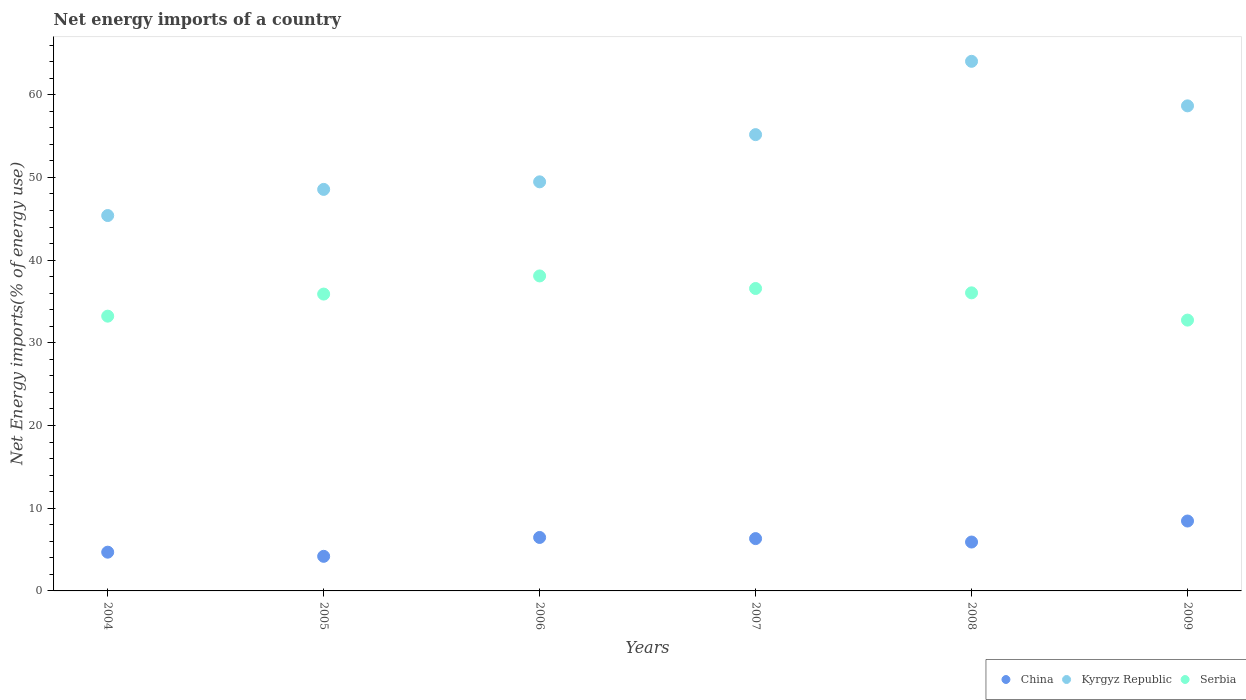How many different coloured dotlines are there?
Your response must be concise. 3. Is the number of dotlines equal to the number of legend labels?
Ensure brevity in your answer.  Yes. What is the net energy imports in Serbia in 2004?
Provide a succinct answer. 33.23. Across all years, what is the maximum net energy imports in China?
Provide a succinct answer. 8.45. Across all years, what is the minimum net energy imports in Kyrgyz Republic?
Offer a very short reply. 45.39. In which year was the net energy imports in Serbia maximum?
Offer a very short reply. 2006. In which year was the net energy imports in Serbia minimum?
Provide a succinct answer. 2009. What is the total net energy imports in Kyrgyz Republic in the graph?
Provide a short and direct response. 321.3. What is the difference between the net energy imports in Serbia in 2006 and that in 2009?
Your answer should be very brief. 5.34. What is the difference between the net energy imports in Kyrgyz Republic in 2008 and the net energy imports in Serbia in 2009?
Your answer should be compact. 31.29. What is the average net energy imports in Serbia per year?
Offer a very short reply. 35.43. In the year 2009, what is the difference between the net energy imports in China and net energy imports in Kyrgyz Republic?
Give a very brief answer. -50.21. What is the ratio of the net energy imports in Kyrgyz Republic in 2005 to that in 2009?
Your answer should be compact. 0.83. What is the difference between the highest and the second highest net energy imports in Kyrgyz Republic?
Ensure brevity in your answer.  5.38. What is the difference between the highest and the lowest net energy imports in Kyrgyz Republic?
Provide a short and direct response. 18.65. Is the sum of the net energy imports in Serbia in 2004 and 2006 greater than the maximum net energy imports in China across all years?
Your response must be concise. Yes. Does the net energy imports in Serbia monotonically increase over the years?
Provide a short and direct response. No. How many dotlines are there?
Ensure brevity in your answer.  3. What is the difference between two consecutive major ticks on the Y-axis?
Offer a very short reply. 10. Does the graph contain any zero values?
Your answer should be compact. No. Where does the legend appear in the graph?
Provide a succinct answer. Bottom right. What is the title of the graph?
Provide a succinct answer. Net energy imports of a country. Does "Brunei Darussalam" appear as one of the legend labels in the graph?
Offer a terse response. No. What is the label or title of the Y-axis?
Give a very brief answer. Net Energy imports(% of energy use). What is the Net Energy imports(% of energy use) in China in 2004?
Make the answer very short. 4.69. What is the Net Energy imports(% of energy use) in Kyrgyz Republic in 2004?
Keep it short and to the point. 45.39. What is the Net Energy imports(% of energy use) in Serbia in 2004?
Provide a short and direct response. 33.23. What is the Net Energy imports(% of energy use) in China in 2005?
Your response must be concise. 4.18. What is the Net Energy imports(% of energy use) of Kyrgyz Republic in 2005?
Offer a very short reply. 48.56. What is the Net Energy imports(% of energy use) of Serbia in 2005?
Offer a very short reply. 35.9. What is the Net Energy imports(% of energy use) in China in 2006?
Provide a short and direct response. 6.47. What is the Net Energy imports(% of energy use) of Kyrgyz Republic in 2006?
Provide a succinct answer. 49.47. What is the Net Energy imports(% of energy use) of Serbia in 2006?
Offer a very short reply. 38.09. What is the Net Energy imports(% of energy use) of China in 2007?
Your answer should be very brief. 6.33. What is the Net Energy imports(% of energy use) in Kyrgyz Republic in 2007?
Ensure brevity in your answer.  55.18. What is the Net Energy imports(% of energy use) of Serbia in 2007?
Your answer should be very brief. 36.57. What is the Net Energy imports(% of energy use) of China in 2008?
Offer a very short reply. 5.91. What is the Net Energy imports(% of energy use) in Kyrgyz Republic in 2008?
Provide a short and direct response. 64.04. What is the Net Energy imports(% of energy use) in Serbia in 2008?
Ensure brevity in your answer.  36.05. What is the Net Energy imports(% of energy use) of China in 2009?
Provide a short and direct response. 8.45. What is the Net Energy imports(% of energy use) in Kyrgyz Republic in 2009?
Your response must be concise. 58.66. What is the Net Energy imports(% of energy use) in Serbia in 2009?
Offer a terse response. 32.75. Across all years, what is the maximum Net Energy imports(% of energy use) in China?
Ensure brevity in your answer.  8.45. Across all years, what is the maximum Net Energy imports(% of energy use) in Kyrgyz Republic?
Give a very brief answer. 64.04. Across all years, what is the maximum Net Energy imports(% of energy use) of Serbia?
Give a very brief answer. 38.09. Across all years, what is the minimum Net Energy imports(% of energy use) in China?
Offer a very short reply. 4.18. Across all years, what is the minimum Net Energy imports(% of energy use) of Kyrgyz Republic?
Your response must be concise. 45.39. Across all years, what is the minimum Net Energy imports(% of energy use) of Serbia?
Give a very brief answer. 32.75. What is the total Net Energy imports(% of energy use) in China in the graph?
Your answer should be very brief. 36.03. What is the total Net Energy imports(% of energy use) in Kyrgyz Republic in the graph?
Keep it short and to the point. 321.3. What is the total Net Energy imports(% of energy use) in Serbia in the graph?
Ensure brevity in your answer.  212.58. What is the difference between the Net Energy imports(% of energy use) of China in 2004 and that in 2005?
Offer a terse response. 0.5. What is the difference between the Net Energy imports(% of energy use) in Kyrgyz Republic in 2004 and that in 2005?
Offer a terse response. -3.16. What is the difference between the Net Energy imports(% of energy use) in Serbia in 2004 and that in 2005?
Your answer should be very brief. -2.67. What is the difference between the Net Energy imports(% of energy use) in China in 2004 and that in 2006?
Keep it short and to the point. -1.78. What is the difference between the Net Energy imports(% of energy use) of Kyrgyz Republic in 2004 and that in 2006?
Give a very brief answer. -4.08. What is the difference between the Net Energy imports(% of energy use) in Serbia in 2004 and that in 2006?
Keep it short and to the point. -4.86. What is the difference between the Net Energy imports(% of energy use) of China in 2004 and that in 2007?
Your response must be concise. -1.64. What is the difference between the Net Energy imports(% of energy use) in Kyrgyz Republic in 2004 and that in 2007?
Provide a short and direct response. -9.78. What is the difference between the Net Energy imports(% of energy use) of Serbia in 2004 and that in 2007?
Give a very brief answer. -3.34. What is the difference between the Net Energy imports(% of energy use) of China in 2004 and that in 2008?
Your response must be concise. -1.23. What is the difference between the Net Energy imports(% of energy use) of Kyrgyz Republic in 2004 and that in 2008?
Provide a short and direct response. -18.65. What is the difference between the Net Energy imports(% of energy use) in Serbia in 2004 and that in 2008?
Provide a succinct answer. -2.82. What is the difference between the Net Energy imports(% of energy use) of China in 2004 and that in 2009?
Offer a terse response. -3.77. What is the difference between the Net Energy imports(% of energy use) of Kyrgyz Republic in 2004 and that in 2009?
Your response must be concise. -13.26. What is the difference between the Net Energy imports(% of energy use) in Serbia in 2004 and that in 2009?
Make the answer very short. 0.48. What is the difference between the Net Energy imports(% of energy use) of China in 2005 and that in 2006?
Provide a succinct answer. -2.28. What is the difference between the Net Energy imports(% of energy use) in Kyrgyz Republic in 2005 and that in 2006?
Your answer should be compact. -0.91. What is the difference between the Net Energy imports(% of energy use) in Serbia in 2005 and that in 2006?
Make the answer very short. -2.19. What is the difference between the Net Energy imports(% of energy use) in China in 2005 and that in 2007?
Keep it short and to the point. -2.14. What is the difference between the Net Energy imports(% of energy use) of Kyrgyz Republic in 2005 and that in 2007?
Provide a succinct answer. -6.62. What is the difference between the Net Energy imports(% of energy use) of Serbia in 2005 and that in 2007?
Keep it short and to the point. -0.67. What is the difference between the Net Energy imports(% of energy use) of China in 2005 and that in 2008?
Offer a terse response. -1.73. What is the difference between the Net Energy imports(% of energy use) in Kyrgyz Republic in 2005 and that in 2008?
Ensure brevity in your answer.  -15.49. What is the difference between the Net Energy imports(% of energy use) of Serbia in 2005 and that in 2008?
Make the answer very short. -0.15. What is the difference between the Net Energy imports(% of energy use) in China in 2005 and that in 2009?
Ensure brevity in your answer.  -4.27. What is the difference between the Net Energy imports(% of energy use) of Kyrgyz Republic in 2005 and that in 2009?
Ensure brevity in your answer.  -10.1. What is the difference between the Net Energy imports(% of energy use) in Serbia in 2005 and that in 2009?
Offer a terse response. 3.15. What is the difference between the Net Energy imports(% of energy use) in China in 2006 and that in 2007?
Provide a short and direct response. 0.14. What is the difference between the Net Energy imports(% of energy use) of Kyrgyz Republic in 2006 and that in 2007?
Ensure brevity in your answer.  -5.71. What is the difference between the Net Energy imports(% of energy use) of Serbia in 2006 and that in 2007?
Make the answer very short. 1.52. What is the difference between the Net Energy imports(% of energy use) in China in 2006 and that in 2008?
Ensure brevity in your answer.  0.55. What is the difference between the Net Energy imports(% of energy use) of Kyrgyz Republic in 2006 and that in 2008?
Your response must be concise. -14.57. What is the difference between the Net Energy imports(% of energy use) of Serbia in 2006 and that in 2008?
Your answer should be compact. 2.04. What is the difference between the Net Energy imports(% of energy use) in China in 2006 and that in 2009?
Your answer should be compact. -1.99. What is the difference between the Net Energy imports(% of energy use) in Kyrgyz Republic in 2006 and that in 2009?
Provide a short and direct response. -9.19. What is the difference between the Net Energy imports(% of energy use) in Serbia in 2006 and that in 2009?
Ensure brevity in your answer.  5.34. What is the difference between the Net Energy imports(% of energy use) of China in 2007 and that in 2008?
Your answer should be very brief. 0.42. What is the difference between the Net Energy imports(% of energy use) of Kyrgyz Republic in 2007 and that in 2008?
Your response must be concise. -8.86. What is the difference between the Net Energy imports(% of energy use) in Serbia in 2007 and that in 2008?
Provide a succinct answer. 0.53. What is the difference between the Net Energy imports(% of energy use) in China in 2007 and that in 2009?
Provide a succinct answer. -2.13. What is the difference between the Net Energy imports(% of energy use) in Kyrgyz Republic in 2007 and that in 2009?
Offer a very short reply. -3.48. What is the difference between the Net Energy imports(% of energy use) in Serbia in 2007 and that in 2009?
Your answer should be compact. 3.82. What is the difference between the Net Energy imports(% of energy use) in China in 2008 and that in 2009?
Keep it short and to the point. -2.54. What is the difference between the Net Energy imports(% of energy use) of Kyrgyz Republic in 2008 and that in 2009?
Ensure brevity in your answer.  5.38. What is the difference between the Net Energy imports(% of energy use) of Serbia in 2008 and that in 2009?
Provide a short and direct response. 3.3. What is the difference between the Net Energy imports(% of energy use) in China in 2004 and the Net Energy imports(% of energy use) in Kyrgyz Republic in 2005?
Offer a very short reply. -43.87. What is the difference between the Net Energy imports(% of energy use) of China in 2004 and the Net Energy imports(% of energy use) of Serbia in 2005?
Offer a very short reply. -31.21. What is the difference between the Net Energy imports(% of energy use) of Kyrgyz Republic in 2004 and the Net Energy imports(% of energy use) of Serbia in 2005?
Provide a succinct answer. 9.5. What is the difference between the Net Energy imports(% of energy use) in China in 2004 and the Net Energy imports(% of energy use) in Kyrgyz Republic in 2006?
Your answer should be very brief. -44.78. What is the difference between the Net Energy imports(% of energy use) in China in 2004 and the Net Energy imports(% of energy use) in Serbia in 2006?
Provide a short and direct response. -33.4. What is the difference between the Net Energy imports(% of energy use) in Kyrgyz Republic in 2004 and the Net Energy imports(% of energy use) in Serbia in 2006?
Make the answer very short. 7.3. What is the difference between the Net Energy imports(% of energy use) in China in 2004 and the Net Energy imports(% of energy use) in Kyrgyz Republic in 2007?
Offer a terse response. -50.49. What is the difference between the Net Energy imports(% of energy use) of China in 2004 and the Net Energy imports(% of energy use) of Serbia in 2007?
Offer a terse response. -31.89. What is the difference between the Net Energy imports(% of energy use) of Kyrgyz Republic in 2004 and the Net Energy imports(% of energy use) of Serbia in 2007?
Provide a short and direct response. 8.82. What is the difference between the Net Energy imports(% of energy use) of China in 2004 and the Net Energy imports(% of energy use) of Kyrgyz Republic in 2008?
Keep it short and to the point. -59.36. What is the difference between the Net Energy imports(% of energy use) of China in 2004 and the Net Energy imports(% of energy use) of Serbia in 2008?
Provide a succinct answer. -31.36. What is the difference between the Net Energy imports(% of energy use) in Kyrgyz Republic in 2004 and the Net Energy imports(% of energy use) in Serbia in 2008?
Make the answer very short. 9.35. What is the difference between the Net Energy imports(% of energy use) of China in 2004 and the Net Energy imports(% of energy use) of Kyrgyz Republic in 2009?
Give a very brief answer. -53.97. What is the difference between the Net Energy imports(% of energy use) in China in 2004 and the Net Energy imports(% of energy use) in Serbia in 2009?
Provide a short and direct response. -28.06. What is the difference between the Net Energy imports(% of energy use) in Kyrgyz Republic in 2004 and the Net Energy imports(% of energy use) in Serbia in 2009?
Provide a succinct answer. 12.64. What is the difference between the Net Energy imports(% of energy use) in China in 2005 and the Net Energy imports(% of energy use) in Kyrgyz Republic in 2006?
Make the answer very short. -45.29. What is the difference between the Net Energy imports(% of energy use) of China in 2005 and the Net Energy imports(% of energy use) of Serbia in 2006?
Your response must be concise. -33.91. What is the difference between the Net Energy imports(% of energy use) of Kyrgyz Republic in 2005 and the Net Energy imports(% of energy use) of Serbia in 2006?
Provide a short and direct response. 10.47. What is the difference between the Net Energy imports(% of energy use) in China in 2005 and the Net Energy imports(% of energy use) in Kyrgyz Republic in 2007?
Offer a very short reply. -50.99. What is the difference between the Net Energy imports(% of energy use) in China in 2005 and the Net Energy imports(% of energy use) in Serbia in 2007?
Ensure brevity in your answer.  -32.39. What is the difference between the Net Energy imports(% of energy use) in Kyrgyz Republic in 2005 and the Net Energy imports(% of energy use) in Serbia in 2007?
Keep it short and to the point. 11.98. What is the difference between the Net Energy imports(% of energy use) in China in 2005 and the Net Energy imports(% of energy use) in Kyrgyz Republic in 2008?
Offer a very short reply. -59.86. What is the difference between the Net Energy imports(% of energy use) in China in 2005 and the Net Energy imports(% of energy use) in Serbia in 2008?
Offer a terse response. -31.86. What is the difference between the Net Energy imports(% of energy use) in Kyrgyz Republic in 2005 and the Net Energy imports(% of energy use) in Serbia in 2008?
Provide a short and direct response. 12.51. What is the difference between the Net Energy imports(% of energy use) in China in 2005 and the Net Energy imports(% of energy use) in Kyrgyz Republic in 2009?
Give a very brief answer. -54.47. What is the difference between the Net Energy imports(% of energy use) in China in 2005 and the Net Energy imports(% of energy use) in Serbia in 2009?
Ensure brevity in your answer.  -28.57. What is the difference between the Net Energy imports(% of energy use) of Kyrgyz Republic in 2005 and the Net Energy imports(% of energy use) of Serbia in 2009?
Your answer should be very brief. 15.81. What is the difference between the Net Energy imports(% of energy use) of China in 2006 and the Net Energy imports(% of energy use) of Kyrgyz Republic in 2007?
Your response must be concise. -48.71. What is the difference between the Net Energy imports(% of energy use) in China in 2006 and the Net Energy imports(% of energy use) in Serbia in 2007?
Provide a succinct answer. -30.11. What is the difference between the Net Energy imports(% of energy use) in Kyrgyz Republic in 2006 and the Net Energy imports(% of energy use) in Serbia in 2007?
Keep it short and to the point. 12.9. What is the difference between the Net Energy imports(% of energy use) of China in 2006 and the Net Energy imports(% of energy use) of Kyrgyz Republic in 2008?
Your answer should be very brief. -57.58. What is the difference between the Net Energy imports(% of energy use) of China in 2006 and the Net Energy imports(% of energy use) of Serbia in 2008?
Offer a very short reply. -29.58. What is the difference between the Net Energy imports(% of energy use) of Kyrgyz Republic in 2006 and the Net Energy imports(% of energy use) of Serbia in 2008?
Give a very brief answer. 13.42. What is the difference between the Net Energy imports(% of energy use) of China in 2006 and the Net Energy imports(% of energy use) of Kyrgyz Republic in 2009?
Give a very brief answer. -52.19. What is the difference between the Net Energy imports(% of energy use) in China in 2006 and the Net Energy imports(% of energy use) in Serbia in 2009?
Give a very brief answer. -26.28. What is the difference between the Net Energy imports(% of energy use) in Kyrgyz Republic in 2006 and the Net Energy imports(% of energy use) in Serbia in 2009?
Your answer should be very brief. 16.72. What is the difference between the Net Energy imports(% of energy use) of China in 2007 and the Net Energy imports(% of energy use) of Kyrgyz Republic in 2008?
Your response must be concise. -57.72. What is the difference between the Net Energy imports(% of energy use) of China in 2007 and the Net Energy imports(% of energy use) of Serbia in 2008?
Give a very brief answer. -29.72. What is the difference between the Net Energy imports(% of energy use) of Kyrgyz Republic in 2007 and the Net Energy imports(% of energy use) of Serbia in 2008?
Provide a succinct answer. 19.13. What is the difference between the Net Energy imports(% of energy use) in China in 2007 and the Net Energy imports(% of energy use) in Kyrgyz Republic in 2009?
Your answer should be very brief. -52.33. What is the difference between the Net Energy imports(% of energy use) in China in 2007 and the Net Energy imports(% of energy use) in Serbia in 2009?
Your response must be concise. -26.42. What is the difference between the Net Energy imports(% of energy use) of Kyrgyz Republic in 2007 and the Net Energy imports(% of energy use) of Serbia in 2009?
Your answer should be very brief. 22.43. What is the difference between the Net Energy imports(% of energy use) in China in 2008 and the Net Energy imports(% of energy use) in Kyrgyz Republic in 2009?
Ensure brevity in your answer.  -52.75. What is the difference between the Net Energy imports(% of energy use) in China in 2008 and the Net Energy imports(% of energy use) in Serbia in 2009?
Ensure brevity in your answer.  -26.84. What is the difference between the Net Energy imports(% of energy use) in Kyrgyz Republic in 2008 and the Net Energy imports(% of energy use) in Serbia in 2009?
Keep it short and to the point. 31.29. What is the average Net Energy imports(% of energy use) in China per year?
Ensure brevity in your answer.  6. What is the average Net Energy imports(% of energy use) in Kyrgyz Republic per year?
Make the answer very short. 53.55. What is the average Net Energy imports(% of energy use) of Serbia per year?
Your answer should be compact. 35.43. In the year 2004, what is the difference between the Net Energy imports(% of energy use) in China and Net Energy imports(% of energy use) in Kyrgyz Republic?
Make the answer very short. -40.71. In the year 2004, what is the difference between the Net Energy imports(% of energy use) of China and Net Energy imports(% of energy use) of Serbia?
Give a very brief answer. -28.54. In the year 2004, what is the difference between the Net Energy imports(% of energy use) in Kyrgyz Republic and Net Energy imports(% of energy use) in Serbia?
Your answer should be very brief. 12.17. In the year 2005, what is the difference between the Net Energy imports(% of energy use) of China and Net Energy imports(% of energy use) of Kyrgyz Republic?
Your answer should be compact. -44.37. In the year 2005, what is the difference between the Net Energy imports(% of energy use) in China and Net Energy imports(% of energy use) in Serbia?
Provide a succinct answer. -31.71. In the year 2005, what is the difference between the Net Energy imports(% of energy use) of Kyrgyz Republic and Net Energy imports(% of energy use) of Serbia?
Your answer should be very brief. 12.66. In the year 2006, what is the difference between the Net Energy imports(% of energy use) of China and Net Energy imports(% of energy use) of Kyrgyz Republic?
Give a very brief answer. -43. In the year 2006, what is the difference between the Net Energy imports(% of energy use) in China and Net Energy imports(% of energy use) in Serbia?
Your answer should be very brief. -31.62. In the year 2006, what is the difference between the Net Energy imports(% of energy use) of Kyrgyz Republic and Net Energy imports(% of energy use) of Serbia?
Your answer should be compact. 11.38. In the year 2007, what is the difference between the Net Energy imports(% of energy use) in China and Net Energy imports(% of energy use) in Kyrgyz Republic?
Ensure brevity in your answer.  -48.85. In the year 2007, what is the difference between the Net Energy imports(% of energy use) of China and Net Energy imports(% of energy use) of Serbia?
Keep it short and to the point. -30.24. In the year 2007, what is the difference between the Net Energy imports(% of energy use) of Kyrgyz Republic and Net Energy imports(% of energy use) of Serbia?
Your answer should be very brief. 18.61. In the year 2008, what is the difference between the Net Energy imports(% of energy use) of China and Net Energy imports(% of energy use) of Kyrgyz Republic?
Your answer should be compact. -58.13. In the year 2008, what is the difference between the Net Energy imports(% of energy use) of China and Net Energy imports(% of energy use) of Serbia?
Your answer should be very brief. -30.13. In the year 2008, what is the difference between the Net Energy imports(% of energy use) in Kyrgyz Republic and Net Energy imports(% of energy use) in Serbia?
Make the answer very short. 28. In the year 2009, what is the difference between the Net Energy imports(% of energy use) in China and Net Energy imports(% of energy use) in Kyrgyz Republic?
Provide a short and direct response. -50.21. In the year 2009, what is the difference between the Net Energy imports(% of energy use) in China and Net Energy imports(% of energy use) in Serbia?
Provide a short and direct response. -24.3. In the year 2009, what is the difference between the Net Energy imports(% of energy use) in Kyrgyz Republic and Net Energy imports(% of energy use) in Serbia?
Offer a terse response. 25.91. What is the ratio of the Net Energy imports(% of energy use) of China in 2004 to that in 2005?
Make the answer very short. 1.12. What is the ratio of the Net Energy imports(% of energy use) in Kyrgyz Republic in 2004 to that in 2005?
Provide a short and direct response. 0.93. What is the ratio of the Net Energy imports(% of energy use) of Serbia in 2004 to that in 2005?
Offer a very short reply. 0.93. What is the ratio of the Net Energy imports(% of energy use) of China in 2004 to that in 2006?
Offer a terse response. 0.72. What is the ratio of the Net Energy imports(% of energy use) of Kyrgyz Republic in 2004 to that in 2006?
Make the answer very short. 0.92. What is the ratio of the Net Energy imports(% of energy use) of Serbia in 2004 to that in 2006?
Offer a very short reply. 0.87. What is the ratio of the Net Energy imports(% of energy use) of China in 2004 to that in 2007?
Make the answer very short. 0.74. What is the ratio of the Net Energy imports(% of energy use) of Kyrgyz Republic in 2004 to that in 2007?
Your answer should be very brief. 0.82. What is the ratio of the Net Energy imports(% of energy use) of Serbia in 2004 to that in 2007?
Make the answer very short. 0.91. What is the ratio of the Net Energy imports(% of energy use) in China in 2004 to that in 2008?
Your answer should be very brief. 0.79. What is the ratio of the Net Energy imports(% of energy use) of Kyrgyz Republic in 2004 to that in 2008?
Your response must be concise. 0.71. What is the ratio of the Net Energy imports(% of energy use) in Serbia in 2004 to that in 2008?
Provide a short and direct response. 0.92. What is the ratio of the Net Energy imports(% of energy use) of China in 2004 to that in 2009?
Your answer should be compact. 0.55. What is the ratio of the Net Energy imports(% of energy use) in Kyrgyz Republic in 2004 to that in 2009?
Your response must be concise. 0.77. What is the ratio of the Net Energy imports(% of energy use) in Serbia in 2004 to that in 2009?
Your response must be concise. 1.01. What is the ratio of the Net Energy imports(% of energy use) of China in 2005 to that in 2006?
Offer a very short reply. 0.65. What is the ratio of the Net Energy imports(% of energy use) of Kyrgyz Republic in 2005 to that in 2006?
Your response must be concise. 0.98. What is the ratio of the Net Energy imports(% of energy use) of Serbia in 2005 to that in 2006?
Give a very brief answer. 0.94. What is the ratio of the Net Energy imports(% of energy use) of China in 2005 to that in 2007?
Offer a terse response. 0.66. What is the ratio of the Net Energy imports(% of energy use) of Kyrgyz Republic in 2005 to that in 2007?
Your answer should be very brief. 0.88. What is the ratio of the Net Energy imports(% of energy use) of Serbia in 2005 to that in 2007?
Your answer should be very brief. 0.98. What is the ratio of the Net Energy imports(% of energy use) of China in 2005 to that in 2008?
Give a very brief answer. 0.71. What is the ratio of the Net Energy imports(% of energy use) of Kyrgyz Republic in 2005 to that in 2008?
Keep it short and to the point. 0.76. What is the ratio of the Net Energy imports(% of energy use) in China in 2005 to that in 2009?
Offer a very short reply. 0.49. What is the ratio of the Net Energy imports(% of energy use) of Kyrgyz Republic in 2005 to that in 2009?
Your answer should be compact. 0.83. What is the ratio of the Net Energy imports(% of energy use) in Serbia in 2005 to that in 2009?
Your response must be concise. 1.1. What is the ratio of the Net Energy imports(% of energy use) of China in 2006 to that in 2007?
Offer a very short reply. 1.02. What is the ratio of the Net Energy imports(% of energy use) of Kyrgyz Republic in 2006 to that in 2007?
Offer a very short reply. 0.9. What is the ratio of the Net Energy imports(% of energy use) in Serbia in 2006 to that in 2007?
Your answer should be very brief. 1.04. What is the ratio of the Net Energy imports(% of energy use) in China in 2006 to that in 2008?
Make the answer very short. 1.09. What is the ratio of the Net Energy imports(% of energy use) of Kyrgyz Republic in 2006 to that in 2008?
Give a very brief answer. 0.77. What is the ratio of the Net Energy imports(% of energy use) in Serbia in 2006 to that in 2008?
Make the answer very short. 1.06. What is the ratio of the Net Energy imports(% of energy use) of China in 2006 to that in 2009?
Your answer should be compact. 0.76. What is the ratio of the Net Energy imports(% of energy use) of Kyrgyz Republic in 2006 to that in 2009?
Ensure brevity in your answer.  0.84. What is the ratio of the Net Energy imports(% of energy use) in Serbia in 2006 to that in 2009?
Ensure brevity in your answer.  1.16. What is the ratio of the Net Energy imports(% of energy use) in China in 2007 to that in 2008?
Offer a terse response. 1.07. What is the ratio of the Net Energy imports(% of energy use) of Kyrgyz Republic in 2007 to that in 2008?
Provide a succinct answer. 0.86. What is the ratio of the Net Energy imports(% of energy use) in Serbia in 2007 to that in 2008?
Offer a very short reply. 1.01. What is the ratio of the Net Energy imports(% of energy use) in China in 2007 to that in 2009?
Provide a succinct answer. 0.75. What is the ratio of the Net Energy imports(% of energy use) in Kyrgyz Republic in 2007 to that in 2009?
Your answer should be very brief. 0.94. What is the ratio of the Net Energy imports(% of energy use) in Serbia in 2007 to that in 2009?
Your answer should be compact. 1.12. What is the ratio of the Net Energy imports(% of energy use) in China in 2008 to that in 2009?
Your answer should be very brief. 0.7. What is the ratio of the Net Energy imports(% of energy use) in Kyrgyz Republic in 2008 to that in 2009?
Your response must be concise. 1.09. What is the ratio of the Net Energy imports(% of energy use) in Serbia in 2008 to that in 2009?
Your answer should be compact. 1.1. What is the difference between the highest and the second highest Net Energy imports(% of energy use) in China?
Offer a very short reply. 1.99. What is the difference between the highest and the second highest Net Energy imports(% of energy use) in Kyrgyz Republic?
Keep it short and to the point. 5.38. What is the difference between the highest and the second highest Net Energy imports(% of energy use) in Serbia?
Ensure brevity in your answer.  1.52. What is the difference between the highest and the lowest Net Energy imports(% of energy use) of China?
Offer a terse response. 4.27. What is the difference between the highest and the lowest Net Energy imports(% of energy use) in Kyrgyz Republic?
Make the answer very short. 18.65. What is the difference between the highest and the lowest Net Energy imports(% of energy use) of Serbia?
Your answer should be compact. 5.34. 